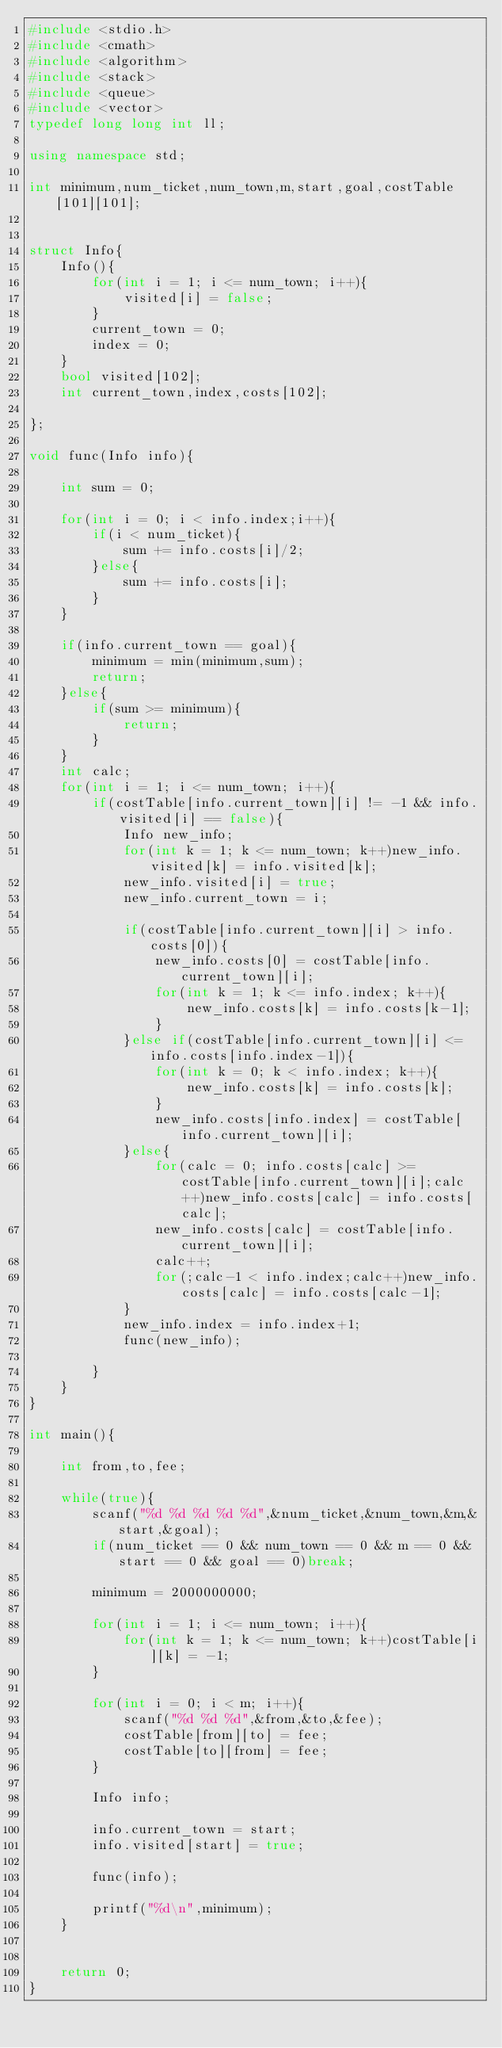Convert code to text. <code><loc_0><loc_0><loc_500><loc_500><_C++_>#include <stdio.h>
#include <cmath>
#include <algorithm>
#include <stack>
#include <queue>
#include <vector>
typedef long long int ll;

using namespace std;

int minimum,num_ticket,num_town,m,start,goal,costTable[101][101];


struct Info{
    Info(){
        for(int i = 1; i <= num_town; i++){
            visited[i] = false;
        }
        current_town = 0;
        index = 0;
    }
    bool visited[102];
    int current_town,index,costs[102];

};

void func(Info info){

    int sum = 0;

    for(int i = 0; i < info.index;i++){
        if(i < num_ticket){
            sum += info.costs[i]/2;
        }else{
            sum += info.costs[i];
        }
    }

    if(info.current_town == goal){
        minimum = min(minimum,sum);
        return;
    }else{
        if(sum >= minimum){
            return;
        }
    }
    int calc;
    for(int i = 1; i <= num_town; i++){
        if(costTable[info.current_town][i] != -1 && info.visited[i] == false){
            Info new_info;
            for(int k = 1; k <= num_town; k++)new_info.visited[k] = info.visited[k];
            new_info.visited[i] = true;
            new_info.current_town = i;

            if(costTable[info.current_town][i] > info.costs[0]){
            	new_info.costs[0] = costTable[info.current_town][i];
            	for(int k = 1; k <= info.index; k++){
            		new_info.costs[k] = info.costs[k-1];
            	}
            }else if(costTable[info.current_town][i] <= info.costs[info.index-1]){
            	for(int k = 0; k < info.index; k++){
            		new_info.costs[k] = info.costs[k];
            	}
            	new_info.costs[info.index] = costTable[info.current_town][i];
            }else{
            	for(calc = 0; info.costs[calc] >= costTable[info.current_town][i];calc++)new_info.costs[calc] = info.costs[calc];
				new_info.costs[calc] = costTable[info.current_town][i];
				calc++;
				for(;calc-1 < info.index;calc++)new_info.costs[calc] = info.costs[calc-1];
            }
            new_info.index = info.index+1;
            func(new_info);

        }
    }
}

int main(){

    int from,to,fee;

    while(true){
        scanf("%d %d %d %d %d",&num_ticket,&num_town,&m,&start,&goal);
        if(num_ticket == 0 && num_town == 0 && m == 0 && start == 0 && goal == 0)break;

        minimum = 2000000000;

        for(int i = 1; i <= num_town; i++){
            for(int k = 1; k <= num_town; k++)costTable[i][k] = -1;
        }

        for(int i = 0; i < m; i++){
            scanf("%d %d %d",&from,&to,&fee);
            costTable[from][to] = fee;
            costTable[to][from] = fee;
        }

        Info info;

        info.current_town = start;
        info.visited[start] = true;

        func(info);

        printf("%d\n",minimum);
    }


    return 0;
}</code> 